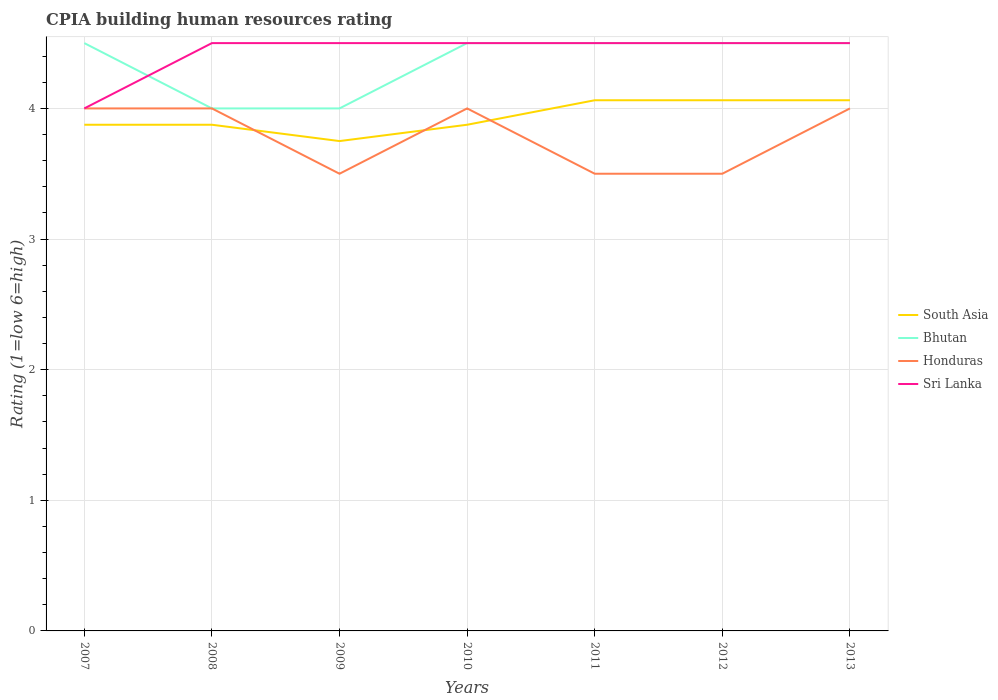Does the line corresponding to Sri Lanka intersect with the line corresponding to Bhutan?
Ensure brevity in your answer.  Yes. Across all years, what is the maximum CPIA rating in Honduras?
Offer a terse response. 3.5. What is the difference between the highest and the lowest CPIA rating in Honduras?
Keep it short and to the point. 4. How many years are there in the graph?
Provide a succinct answer. 7. Are the values on the major ticks of Y-axis written in scientific E-notation?
Offer a very short reply. No. Where does the legend appear in the graph?
Your answer should be very brief. Center right. What is the title of the graph?
Your answer should be very brief. CPIA building human resources rating. Does "Pacific island small states" appear as one of the legend labels in the graph?
Your response must be concise. No. What is the label or title of the Y-axis?
Provide a short and direct response. Rating (1=low 6=high). What is the Rating (1=low 6=high) in South Asia in 2007?
Provide a short and direct response. 3.88. What is the Rating (1=low 6=high) in Bhutan in 2007?
Your response must be concise. 4.5. What is the Rating (1=low 6=high) in Honduras in 2007?
Provide a succinct answer. 4. What is the Rating (1=low 6=high) in Sri Lanka in 2007?
Offer a very short reply. 4. What is the Rating (1=low 6=high) in South Asia in 2008?
Provide a succinct answer. 3.88. What is the Rating (1=low 6=high) of Sri Lanka in 2008?
Give a very brief answer. 4.5. What is the Rating (1=low 6=high) of South Asia in 2009?
Make the answer very short. 3.75. What is the Rating (1=low 6=high) in Honduras in 2009?
Offer a terse response. 3.5. What is the Rating (1=low 6=high) in Sri Lanka in 2009?
Offer a terse response. 4.5. What is the Rating (1=low 6=high) in South Asia in 2010?
Your response must be concise. 3.88. What is the Rating (1=low 6=high) of Bhutan in 2010?
Offer a very short reply. 4.5. What is the Rating (1=low 6=high) of Honduras in 2010?
Offer a terse response. 4. What is the Rating (1=low 6=high) of Sri Lanka in 2010?
Your answer should be compact. 4.5. What is the Rating (1=low 6=high) of South Asia in 2011?
Your response must be concise. 4.06. What is the Rating (1=low 6=high) in South Asia in 2012?
Your answer should be compact. 4.06. What is the Rating (1=low 6=high) of Bhutan in 2012?
Provide a short and direct response. 4.5. What is the Rating (1=low 6=high) in Honduras in 2012?
Make the answer very short. 3.5. What is the Rating (1=low 6=high) in Sri Lanka in 2012?
Your answer should be very brief. 4.5. What is the Rating (1=low 6=high) in South Asia in 2013?
Provide a short and direct response. 4.06. What is the Rating (1=low 6=high) of Bhutan in 2013?
Ensure brevity in your answer.  4.5. What is the Rating (1=low 6=high) in Honduras in 2013?
Your response must be concise. 4. What is the Rating (1=low 6=high) in Sri Lanka in 2013?
Your response must be concise. 4.5. Across all years, what is the maximum Rating (1=low 6=high) of South Asia?
Offer a very short reply. 4.06. Across all years, what is the maximum Rating (1=low 6=high) of Bhutan?
Your answer should be very brief. 4.5. Across all years, what is the maximum Rating (1=low 6=high) in Honduras?
Your response must be concise. 4. Across all years, what is the minimum Rating (1=low 6=high) in South Asia?
Provide a succinct answer. 3.75. Across all years, what is the minimum Rating (1=low 6=high) of Honduras?
Your answer should be compact. 3.5. What is the total Rating (1=low 6=high) in South Asia in the graph?
Provide a short and direct response. 27.56. What is the total Rating (1=low 6=high) of Bhutan in the graph?
Ensure brevity in your answer.  30.5. What is the total Rating (1=low 6=high) of Honduras in the graph?
Make the answer very short. 26.5. What is the total Rating (1=low 6=high) of Sri Lanka in the graph?
Your response must be concise. 31. What is the difference between the Rating (1=low 6=high) of South Asia in 2007 and that in 2008?
Ensure brevity in your answer.  0. What is the difference between the Rating (1=low 6=high) in Honduras in 2007 and that in 2008?
Your answer should be compact. 0. What is the difference between the Rating (1=low 6=high) in Sri Lanka in 2007 and that in 2008?
Make the answer very short. -0.5. What is the difference between the Rating (1=low 6=high) in South Asia in 2007 and that in 2009?
Ensure brevity in your answer.  0.12. What is the difference between the Rating (1=low 6=high) in Bhutan in 2007 and that in 2009?
Make the answer very short. 0.5. What is the difference between the Rating (1=low 6=high) of Honduras in 2007 and that in 2009?
Ensure brevity in your answer.  0.5. What is the difference between the Rating (1=low 6=high) of Sri Lanka in 2007 and that in 2009?
Your answer should be compact. -0.5. What is the difference between the Rating (1=low 6=high) in Bhutan in 2007 and that in 2010?
Give a very brief answer. 0. What is the difference between the Rating (1=low 6=high) in Sri Lanka in 2007 and that in 2010?
Offer a terse response. -0.5. What is the difference between the Rating (1=low 6=high) in South Asia in 2007 and that in 2011?
Offer a terse response. -0.19. What is the difference between the Rating (1=low 6=high) in Honduras in 2007 and that in 2011?
Your answer should be very brief. 0.5. What is the difference between the Rating (1=low 6=high) in South Asia in 2007 and that in 2012?
Provide a short and direct response. -0.19. What is the difference between the Rating (1=low 6=high) of South Asia in 2007 and that in 2013?
Provide a succinct answer. -0.19. What is the difference between the Rating (1=low 6=high) of Bhutan in 2008 and that in 2009?
Your answer should be very brief. 0. What is the difference between the Rating (1=low 6=high) of Sri Lanka in 2008 and that in 2009?
Offer a very short reply. 0. What is the difference between the Rating (1=low 6=high) of Honduras in 2008 and that in 2010?
Your response must be concise. 0. What is the difference between the Rating (1=low 6=high) of South Asia in 2008 and that in 2011?
Your answer should be very brief. -0.19. What is the difference between the Rating (1=low 6=high) in Sri Lanka in 2008 and that in 2011?
Offer a very short reply. 0. What is the difference between the Rating (1=low 6=high) in South Asia in 2008 and that in 2012?
Offer a very short reply. -0.19. What is the difference between the Rating (1=low 6=high) of Bhutan in 2008 and that in 2012?
Provide a short and direct response. -0.5. What is the difference between the Rating (1=low 6=high) in Honduras in 2008 and that in 2012?
Your answer should be very brief. 0.5. What is the difference between the Rating (1=low 6=high) in South Asia in 2008 and that in 2013?
Your answer should be very brief. -0.19. What is the difference between the Rating (1=low 6=high) of Bhutan in 2008 and that in 2013?
Offer a terse response. -0.5. What is the difference between the Rating (1=low 6=high) in Honduras in 2008 and that in 2013?
Your response must be concise. 0. What is the difference between the Rating (1=low 6=high) in South Asia in 2009 and that in 2010?
Your answer should be very brief. -0.12. What is the difference between the Rating (1=low 6=high) of Sri Lanka in 2009 and that in 2010?
Provide a short and direct response. 0. What is the difference between the Rating (1=low 6=high) of South Asia in 2009 and that in 2011?
Your answer should be compact. -0.31. What is the difference between the Rating (1=low 6=high) of South Asia in 2009 and that in 2012?
Your response must be concise. -0.31. What is the difference between the Rating (1=low 6=high) in Honduras in 2009 and that in 2012?
Keep it short and to the point. 0. What is the difference between the Rating (1=low 6=high) in South Asia in 2009 and that in 2013?
Your response must be concise. -0.31. What is the difference between the Rating (1=low 6=high) in South Asia in 2010 and that in 2011?
Provide a short and direct response. -0.19. What is the difference between the Rating (1=low 6=high) in Bhutan in 2010 and that in 2011?
Give a very brief answer. 0. What is the difference between the Rating (1=low 6=high) of Honduras in 2010 and that in 2011?
Provide a succinct answer. 0.5. What is the difference between the Rating (1=low 6=high) of Sri Lanka in 2010 and that in 2011?
Your answer should be compact. 0. What is the difference between the Rating (1=low 6=high) in South Asia in 2010 and that in 2012?
Your answer should be compact. -0.19. What is the difference between the Rating (1=low 6=high) in Bhutan in 2010 and that in 2012?
Your answer should be very brief. 0. What is the difference between the Rating (1=low 6=high) in Honduras in 2010 and that in 2012?
Provide a succinct answer. 0.5. What is the difference between the Rating (1=low 6=high) in Sri Lanka in 2010 and that in 2012?
Provide a succinct answer. 0. What is the difference between the Rating (1=low 6=high) of South Asia in 2010 and that in 2013?
Your response must be concise. -0.19. What is the difference between the Rating (1=low 6=high) in Bhutan in 2010 and that in 2013?
Keep it short and to the point. 0. What is the difference between the Rating (1=low 6=high) of Bhutan in 2011 and that in 2012?
Provide a succinct answer. 0. What is the difference between the Rating (1=low 6=high) of South Asia in 2011 and that in 2013?
Your answer should be very brief. 0. What is the difference between the Rating (1=low 6=high) of Bhutan in 2011 and that in 2013?
Give a very brief answer. 0. What is the difference between the Rating (1=low 6=high) of Sri Lanka in 2011 and that in 2013?
Ensure brevity in your answer.  0. What is the difference between the Rating (1=low 6=high) of Bhutan in 2012 and that in 2013?
Keep it short and to the point. 0. What is the difference between the Rating (1=low 6=high) of South Asia in 2007 and the Rating (1=low 6=high) of Bhutan in 2008?
Your response must be concise. -0.12. What is the difference between the Rating (1=low 6=high) of South Asia in 2007 and the Rating (1=low 6=high) of Honduras in 2008?
Your response must be concise. -0.12. What is the difference between the Rating (1=low 6=high) of South Asia in 2007 and the Rating (1=low 6=high) of Sri Lanka in 2008?
Keep it short and to the point. -0.62. What is the difference between the Rating (1=low 6=high) of Bhutan in 2007 and the Rating (1=low 6=high) of Honduras in 2008?
Keep it short and to the point. 0.5. What is the difference between the Rating (1=low 6=high) of Honduras in 2007 and the Rating (1=low 6=high) of Sri Lanka in 2008?
Make the answer very short. -0.5. What is the difference between the Rating (1=low 6=high) in South Asia in 2007 and the Rating (1=low 6=high) in Bhutan in 2009?
Provide a short and direct response. -0.12. What is the difference between the Rating (1=low 6=high) of South Asia in 2007 and the Rating (1=low 6=high) of Sri Lanka in 2009?
Your answer should be compact. -0.62. What is the difference between the Rating (1=low 6=high) of Bhutan in 2007 and the Rating (1=low 6=high) of Honduras in 2009?
Offer a very short reply. 1. What is the difference between the Rating (1=low 6=high) in Bhutan in 2007 and the Rating (1=low 6=high) in Sri Lanka in 2009?
Give a very brief answer. 0. What is the difference between the Rating (1=low 6=high) of Honduras in 2007 and the Rating (1=low 6=high) of Sri Lanka in 2009?
Your response must be concise. -0.5. What is the difference between the Rating (1=low 6=high) of South Asia in 2007 and the Rating (1=low 6=high) of Bhutan in 2010?
Ensure brevity in your answer.  -0.62. What is the difference between the Rating (1=low 6=high) in South Asia in 2007 and the Rating (1=low 6=high) in Honduras in 2010?
Give a very brief answer. -0.12. What is the difference between the Rating (1=low 6=high) in South Asia in 2007 and the Rating (1=low 6=high) in Sri Lanka in 2010?
Provide a short and direct response. -0.62. What is the difference between the Rating (1=low 6=high) of Bhutan in 2007 and the Rating (1=low 6=high) of Honduras in 2010?
Offer a very short reply. 0.5. What is the difference between the Rating (1=low 6=high) of South Asia in 2007 and the Rating (1=low 6=high) of Bhutan in 2011?
Make the answer very short. -0.62. What is the difference between the Rating (1=low 6=high) of South Asia in 2007 and the Rating (1=low 6=high) of Honduras in 2011?
Keep it short and to the point. 0.38. What is the difference between the Rating (1=low 6=high) of South Asia in 2007 and the Rating (1=low 6=high) of Sri Lanka in 2011?
Your response must be concise. -0.62. What is the difference between the Rating (1=low 6=high) in Bhutan in 2007 and the Rating (1=low 6=high) in Sri Lanka in 2011?
Your answer should be compact. 0. What is the difference between the Rating (1=low 6=high) of South Asia in 2007 and the Rating (1=low 6=high) of Bhutan in 2012?
Offer a very short reply. -0.62. What is the difference between the Rating (1=low 6=high) of South Asia in 2007 and the Rating (1=low 6=high) of Honduras in 2012?
Your answer should be compact. 0.38. What is the difference between the Rating (1=low 6=high) in South Asia in 2007 and the Rating (1=low 6=high) in Sri Lanka in 2012?
Provide a succinct answer. -0.62. What is the difference between the Rating (1=low 6=high) in Bhutan in 2007 and the Rating (1=low 6=high) in Honduras in 2012?
Your response must be concise. 1. What is the difference between the Rating (1=low 6=high) in Bhutan in 2007 and the Rating (1=low 6=high) in Sri Lanka in 2012?
Offer a very short reply. 0. What is the difference between the Rating (1=low 6=high) of Honduras in 2007 and the Rating (1=low 6=high) of Sri Lanka in 2012?
Provide a succinct answer. -0.5. What is the difference between the Rating (1=low 6=high) of South Asia in 2007 and the Rating (1=low 6=high) of Bhutan in 2013?
Keep it short and to the point. -0.62. What is the difference between the Rating (1=low 6=high) of South Asia in 2007 and the Rating (1=low 6=high) of Honduras in 2013?
Your response must be concise. -0.12. What is the difference between the Rating (1=low 6=high) of South Asia in 2007 and the Rating (1=low 6=high) of Sri Lanka in 2013?
Ensure brevity in your answer.  -0.62. What is the difference between the Rating (1=low 6=high) in Bhutan in 2007 and the Rating (1=low 6=high) in Honduras in 2013?
Provide a short and direct response. 0.5. What is the difference between the Rating (1=low 6=high) of Honduras in 2007 and the Rating (1=low 6=high) of Sri Lanka in 2013?
Provide a succinct answer. -0.5. What is the difference between the Rating (1=low 6=high) of South Asia in 2008 and the Rating (1=low 6=high) of Bhutan in 2009?
Keep it short and to the point. -0.12. What is the difference between the Rating (1=low 6=high) in South Asia in 2008 and the Rating (1=low 6=high) in Sri Lanka in 2009?
Your answer should be very brief. -0.62. What is the difference between the Rating (1=low 6=high) in Bhutan in 2008 and the Rating (1=low 6=high) in Honduras in 2009?
Give a very brief answer. 0.5. What is the difference between the Rating (1=low 6=high) in South Asia in 2008 and the Rating (1=low 6=high) in Bhutan in 2010?
Ensure brevity in your answer.  -0.62. What is the difference between the Rating (1=low 6=high) in South Asia in 2008 and the Rating (1=low 6=high) in Honduras in 2010?
Keep it short and to the point. -0.12. What is the difference between the Rating (1=low 6=high) in South Asia in 2008 and the Rating (1=low 6=high) in Sri Lanka in 2010?
Your answer should be compact. -0.62. What is the difference between the Rating (1=low 6=high) of Bhutan in 2008 and the Rating (1=low 6=high) of Honduras in 2010?
Your response must be concise. 0. What is the difference between the Rating (1=low 6=high) of South Asia in 2008 and the Rating (1=low 6=high) of Bhutan in 2011?
Your response must be concise. -0.62. What is the difference between the Rating (1=low 6=high) in South Asia in 2008 and the Rating (1=low 6=high) in Sri Lanka in 2011?
Provide a succinct answer. -0.62. What is the difference between the Rating (1=low 6=high) in Bhutan in 2008 and the Rating (1=low 6=high) in Honduras in 2011?
Keep it short and to the point. 0.5. What is the difference between the Rating (1=low 6=high) of Bhutan in 2008 and the Rating (1=low 6=high) of Sri Lanka in 2011?
Your response must be concise. -0.5. What is the difference between the Rating (1=low 6=high) of South Asia in 2008 and the Rating (1=low 6=high) of Bhutan in 2012?
Your response must be concise. -0.62. What is the difference between the Rating (1=low 6=high) in South Asia in 2008 and the Rating (1=low 6=high) in Sri Lanka in 2012?
Keep it short and to the point. -0.62. What is the difference between the Rating (1=low 6=high) in Honduras in 2008 and the Rating (1=low 6=high) in Sri Lanka in 2012?
Offer a terse response. -0.5. What is the difference between the Rating (1=low 6=high) of South Asia in 2008 and the Rating (1=low 6=high) of Bhutan in 2013?
Your response must be concise. -0.62. What is the difference between the Rating (1=low 6=high) in South Asia in 2008 and the Rating (1=low 6=high) in Honduras in 2013?
Make the answer very short. -0.12. What is the difference between the Rating (1=low 6=high) in South Asia in 2008 and the Rating (1=low 6=high) in Sri Lanka in 2013?
Ensure brevity in your answer.  -0.62. What is the difference between the Rating (1=low 6=high) of Bhutan in 2008 and the Rating (1=low 6=high) of Sri Lanka in 2013?
Make the answer very short. -0.5. What is the difference between the Rating (1=low 6=high) of South Asia in 2009 and the Rating (1=low 6=high) of Bhutan in 2010?
Provide a succinct answer. -0.75. What is the difference between the Rating (1=low 6=high) of South Asia in 2009 and the Rating (1=low 6=high) of Sri Lanka in 2010?
Your response must be concise. -0.75. What is the difference between the Rating (1=low 6=high) in South Asia in 2009 and the Rating (1=low 6=high) in Bhutan in 2011?
Your answer should be compact. -0.75. What is the difference between the Rating (1=low 6=high) in South Asia in 2009 and the Rating (1=low 6=high) in Sri Lanka in 2011?
Your response must be concise. -0.75. What is the difference between the Rating (1=low 6=high) of Bhutan in 2009 and the Rating (1=low 6=high) of Sri Lanka in 2011?
Give a very brief answer. -0.5. What is the difference between the Rating (1=low 6=high) of Honduras in 2009 and the Rating (1=low 6=high) of Sri Lanka in 2011?
Ensure brevity in your answer.  -1. What is the difference between the Rating (1=low 6=high) of South Asia in 2009 and the Rating (1=low 6=high) of Bhutan in 2012?
Your answer should be very brief. -0.75. What is the difference between the Rating (1=low 6=high) in South Asia in 2009 and the Rating (1=low 6=high) in Honduras in 2012?
Keep it short and to the point. 0.25. What is the difference between the Rating (1=low 6=high) of South Asia in 2009 and the Rating (1=low 6=high) of Sri Lanka in 2012?
Your answer should be compact. -0.75. What is the difference between the Rating (1=low 6=high) of Bhutan in 2009 and the Rating (1=low 6=high) of Honduras in 2012?
Make the answer very short. 0.5. What is the difference between the Rating (1=low 6=high) in Bhutan in 2009 and the Rating (1=low 6=high) in Sri Lanka in 2012?
Your answer should be very brief. -0.5. What is the difference between the Rating (1=low 6=high) in South Asia in 2009 and the Rating (1=low 6=high) in Bhutan in 2013?
Keep it short and to the point. -0.75. What is the difference between the Rating (1=low 6=high) of South Asia in 2009 and the Rating (1=low 6=high) of Sri Lanka in 2013?
Your response must be concise. -0.75. What is the difference between the Rating (1=low 6=high) in Bhutan in 2009 and the Rating (1=low 6=high) in Honduras in 2013?
Give a very brief answer. 0. What is the difference between the Rating (1=low 6=high) in South Asia in 2010 and the Rating (1=low 6=high) in Bhutan in 2011?
Your answer should be compact. -0.62. What is the difference between the Rating (1=low 6=high) in South Asia in 2010 and the Rating (1=low 6=high) in Sri Lanka in 2011?
Keep it short and to the point. -0.62. What is the difference between the Rating (1=low 6=high) in Bhutan in 2010 and the Rating (1=low 6=high) in Sri Lanka in 2011?
Your response must be concise. 0. What is the difference between the Rating (1=low 6=high) of Honduras in 2010 and the Rating (1=low 6=high) of Sri Lanka in 2011?
Keep it short and to the point. -0.5. What is the difference between the Rating (1=low 6=high) in South Asia in 2010 and the Rating (1=low 6=high) in Bhutan in 2012?
Give a very brief answer. -0.62. What is the difference between the Rating (1=low 6=high) of South Asia in 2010 and the Rating (1=low 6=high) of Honduras in 2012?
Offer a terse response. 0.38. What is the difference between the Rating (1=low 6=high) in South Asia in 2010 and the Rating (1=low 6=high) in Sri Lanka in 2012?
Keep it short and to the point. -0.62. What is the difference between the Rating (1=low 6=high) of Bhutan in 2010 and the Rating (1=low 6=high) of Sri Lanka in 2012?
Your answer should be very brief. 0. What is the difference between the Rating (1=low 6=high) of South Asia in 2010 and the Rating (1=low 6=high) of Bhutan in 2013?
Ensure brevity in your answer.  -0.62. What is the difference between the Rating (1=low 6=high) of South Asia in 2010 and the Rating (1=low 6=high) of Honduras in 2013?
Provide a short and direct response. -0.12. What is the difference between the Rating (1=low 6=high) in South Asia in 2010 and the Rating (1=low 6=high) in Sri Lanka in 2013?
Your answer should be compact. -0.62. What is the difference between the Rating (1=low 6=high) of South Asia in 2011 and the Rating (1=low 6=high) of Bhutan in 2012?
Your answer should be compact. -0.44. What is the difference between the Rating (1=low 6=high) in South Asia in 2011 and the Rating (1=low 6=high) in Honduras in 2012?
Give a very brief answer. 0.56. What is the difference between the Rating (1=low 6=high) of South Asia in 2011 and the Rating (1=low 6=high) of Sri Lanka in 2012?
Make the answer very short. -0.44. What is the difference between the Rating (1=low 6=high) in Bhutan in 2011 and the Rating (1=low 6=high) in Honduras in 2012?
Make the answer very short. 1. What is the difference between the Rating (1=low 6=high) in Honduras in 2011 and the Rating (1=low 6=high) in Sri Lanka in 2012?
Ensure brevity in your answer.  -1. What is the difference between the Rating (1=low 6=high) in South Asia in 2011 and the Rating (1=low 6=high) in Bhutan in 2013?
Your answer should be very brief. -0.44. What is the difference between the Rating (1=low 6=high) of South Asia in 2011 and the Rating (1=low 6=high) of Honduras in 2013?
Make the answer very short. 0.06. What is the difference between the Rating (1=low 6=high) in South Asia in 2011 and the Rating (1=low 6=high) in Sri Lanka in 2013?
Your answer should be very brief. -0.44. What is the difference between the Rating (1=low 6=high) of South Asia in 2012 and the Rating (1=low 6=high) of Bhutan in 2013?
Your answer should be very brief. -0.44. What is the difference between the Rating (1=low 6=high) of South Asia in 2012 and the Rating (1=low 6=high) of Honduras in 2013?
Your answer should be compact. 0.06. What is the difference between the Rating (1=low 6=high) of South Asia in 2012 and the Rating (1=low 6=high) of Sri Lanka in 2013?
Provide a succinct answer. -0.44. What is the difference between the Rating (1=low 6=high) in Honduras in 2012 and the Rating (1=low 6=high) in Sri Lanka in 2013?
Your answer should be very brief. -1. What is the average Rating (1=low 6=high) of South Asia per year?
Give a very brief answer. 3.94. What is the average Rating (1=low 6=high) in Bhutan per year?
Ensure brevity in your answer.  4.36. What is the average Rating (1=low 6=high) in Honduras per year?
Your response must be concise. 3.79. What is the average Rating (1=low 6=high) of Sri Lanka per year?
Your response must be concise. 4.43. In the year 2007, what is the difference between the Rating (1=low 6=high) in South Asia and Rating (1=low 6=high) in Bhutan?
Provide a short and direct response. -0.62. In the year 2007, what is the difference between the Rating (1=low 6=high) in South Asia and Rating (1=low 6=high) in Honduras?
Your answer should be very brief. -0.12. In the year 2007, what is the difference between the Rating (1=low 6=high) of South Asia and Rating (1=low 6=high) of Sri Lanka?
Make the answer very short. -0.12. In the year 2007, what is the difference between the Rating (1=low 6=high) of Bhutan and Rating (1=low 6=high) of Honduras?
Offer a very short reply. 0.5. In the year 2008, what is the difference between the Rating (1=low 6=high) of South Asia and Rating (1=low 6=high) of Bhutan?
Make the answer very short. -0.12. In the year 2008, what is the difference between the Rating (1=low 6=high) in South Asia and Rating (1=low 6=high) in Honduras?
Keep it short and to the point. -0.12. In the year 2008, what is the difference between the Rating (1=low 6=high) of South Asia and Rating (1=low 6=high) of Sri Lanka?
Your answer should be very brief. -0.62. In the year 2008, what is the difference between the Rating (1=low 6=high) in Bhutan and Rating (1=low 6=high) in Honduras?
Make the answer very short. 0. In the year 2009, what is the difference between the Rating (1=low 6=high) of South Asia and Rating (1=low 6=high) of Honduras?
Your response must be concise. 0.25. In the year 2009, what is the difference between the Rating (1=low 6=high) of South Asia and Rating (1=low 6=high) of Sri Lanka?
Ensure brevity in your answer.  -0.75. In the year 2009, what is the difference between the Rating (1=low 6=high) in Bhutan and Rating (1=low 6=high) in Honduras?
Provide a short and direct response. 0.5. In the year 2009, what is the difference between the Rating (1=low 6=high) of Bhutan and Rating (1=low 6=high) of Sri Lanka?
Offer a terse response. -0.5. In the year 2010, what is the difference between the Rating (1=low 6=high) in South Asia and Rating (1=low 6=high) in Bhutan?
Your response must be concise. -0.62. In the year 2010, what is the difference between the Rating (1=low 6=high) in South Asia and Rating (1=low 6=high) in Honduras?
Make the answer very short. -0.12. In the year 2010, what is the difference between the Rating (1=low 6=high) of South Asia and Rating (1=low 6=high) of Sri Lanka?
Your response must be concise. -0.62. In the year 2010, what is the difference between the Rating (1=low 6=high) in Bhutan and Rating (1=low 6=high) in Honduras?
Offer a very short reply. 0.5. In the year 2010, what is the difference between the Rating (1=low 6=high) of Bhutan and Rating (1=low 6=high) of Sri Lanka?
Your answer should be very brief. 0. In the year 2010, what is the difference between the Rating (1=low 6=high) of Honduras and Rating (1=low 6=high) of Sri Lanka?
Offer a very short reply. -0.5. In the year 2011, what is the difference between the Rating (1=low 6=high) in South Asia and Rating (1=low 6=high) in Bhutan?
Your response must be concise. -0.44. In the year 2011, what is the difference between the Rating (1=low 6=high) of South Asia and Rating (1=low 6=high) of Honduras?
Ensure brevity in your answer.  0.56. In the year 2011, what is the difference between the Rating (1=low 6=high) of South Asia and Rating (1=low 6=high) of Sri Lanka?
Give a very brief answer. -0.44. In the year 2011, what is the difference between the Rating (1=low 6=high) of Bhutan and Rating (1=low 6=high) of Honduras?
Give a very brief answer. 1. In the year 2011, what is the difference between the Rating (1=low 6=high) in Honduras and Rating (1=low 6=high) in Sri Lanka?
Provide a succinct answer. -1. In the year 2012, what is the difference between the Rating (1=low 6=high) of South Asia and Rating (1=low 6=high) of Bhutan?
Your response must be concise. -0.44. In the year 2012, what is the difference between the Rating (1=low 6=high) in South Asia and Rating (1=low 6=high) in Honduras?
Offer a terse response. 0.56. In the year 2012, what is the difference between the Rating (1=low 6=high) of South Asia and Rating (1=low 6=high) of Sri Lanka?
Make the answer very short. -0.44. In the year 2012, what is the difference between the Rating (1=low 6=high) of Bhutan and Rating (1=low 6=high) of Honduras?
Keep it short and to the point. 1. In the year 2012, what is the difference between the Rating (1=low 6=high) of Honduras and Rating (1=low 6=high) of Sri Lanka?
Your answer should be compact. -1. In the year 2013, what is the difference between the Rating (1=low 6=high) in South Asia and Rating (1=low 6=high) in Bhutan?
Your answer should be compact. -0.44. In the year 2013, what is the difference between the Rating (1=low 6=high) in South Asia and Rating (1=low 6=high) in Honduras?
Keep it short and to the point. 0.06. In the year 2013, what is the difference between the Rating (1=low 6=high) in South Asia and Rating (1=low 6=high) in Sri Lanka?
Give a very brief answer. -0.44. What is the ratio of the Rating (1=low 6=high) of South Asia in 2007 to that in 2008?
Offer a terse response. 1. What is the ratio of the Rating (1=low 6=high) in Bhutan in 2007 to that in 2008?
Provide a short and direct response. 1.12. What is the ratio of the Rating (1=low 6=high) of Sri Lanka in 2007 to that in 2008?
Ensure brevity in your answer.  0.89. What is the ratio of the Rating (1=low 6=high) of South Asia in 2007 to that in 2009?
Make the answer very short. 1.03. What is the ratio of the Rating (1=low 6=high) of South Asia in 2007 to that in 2010?
Your answer should be very brief. 1. What is the ratio of the Rating (1=low 6=high) in South Asia in 2007 to that in 2011?
Provide a succinct answer. 0.95. What is the ratio of the Rating (1=low 6=high) of Honduras in 2007 to that in 2011?
Your answer should be very brief. 1.14. What is the ratio of the Rating (1=low 6=high) in South Asia in 2007 to that in 2012?
Make the answer very short. 0.95. What is the ratio of the Rating (1=low 6=high) of Bhutan in 2007 to that in 2012?
Your answer should be very brief. 1. What is the ratio of the Rating (1=low 6=high) in Honduras in 2007 to that in 2012?
Keep it short and to the point. 1.14. What is the ratio of the Rating (1=low 6=high) of South Asia in 2007 to that in 2013?
Give a very brief answer. 0.95. What is the ratio of the Rating (1=low 6=high) of Honduras in 2007 to that in 2013?
Offer a terse response. 1. What is the ratio of the Rating (1=low 6=high) in South Asia in 2008 to that in 2010?
Ensure brevity in your answer.  1. What is the ratio of the Rating (1=low 6=high) of Bhutan in 2008 to that in 2010?
Make the answer very short. 0.89. What is the ratio of the Rating (1=low 6=high) in Honduras in 2008 to that in 2010?
Provide a short and direct response. 1. What is the ratio of the Rating (1=low 6=high) of South Asia in 2008 to that in 2011?
Keep it short and to the point. 0.95. What is the ratio of the Rating (1=low 6=high) of Bhutan in 2008 to that in 2011?
Your response must be concise. 0.89. What is the ratio of the Rating (1=low 6=high) of Sri Lanka in 2008 to that in 2011?
Your answer should be very brief. 1. What is the ratio of the Rating (1=low 6=high) in South Asia in 2008 to that in 2012?
Make the answer very short. 0.95. What is the ratio of the Rating (1=low 6=high) in Bhutan in 2008 to that in 2012?
Give a very brief answer. 0.89. What is the ratio of the Rating (1=low 6=high) of South Asia in 2008 to that in 2013?
Ensure brevity in your answer.  0.95. What is the ratio of the Rating (1=low 6=high) of Bhutan in 2008 to that in 2013?
Offer a very short reply. 0.89. What is the ratio of the Rating (1=low 6=high) in Sri Lanka in 2009 to that in 2011?
Ensure brevity in your answer.  1. What is the ratio of the Rating (1=low 6=high) of South Asia in 2009 to that in 2012?
Make the answer very short. 0.92. What is the ratio of the Rating (1=low 6=high) in Sri Lanka in 2009 to that in 2012?
Offer a very short reply. 1. What is the ratio of the Rating (1=low 6=high) in Bhutan in 2009 to that in 2013?
Your response must be concise. 0.89. What is the ratio of the Rating (1=low 6=high) of Honduras in 2009 to that in 2013?
Provide a succinct answer. 0.88. What is the ratio of the Rating (1=low 6=high) of Sri Lanka in 2009 to that in 2013?
Ensure brevity in your answer.  1. What is the ratio of the Rating (1=low 6=high) in South Asia in 2010 to that in 2011?
Provide a succinct answer. 0.95. What is the ratio of the Rating (1=low 6=high) in Honduras in 2010 to that in 2011?
Your answer should be compact. 1.14. What is the ratio of the Rating (1=low 6=high) of South Asia in 2010 to that in 2012?
Offer a terse response. 0.95. What is the ratio of the Rating (1=low 6=high) of Bhutan in 2010 to that in 2012?
Provide a short and direct response. 1. What is the ratio of the Rating (1=low 6=high) of South Asia in 2010 to that in 2013?
Your answer should be compact. 0.95. What is the ratio of the Rating (1=low 6=high) in Bhutan in 2010 to that in 2013?
Keep it short and to the point. 1. What is the ratio of the Rating (1=low 6=high) of South Asia in 2011 to that in 2012?
Offer a terse response. 1. What is the ratio of the Rating (1=low 6=high) in Honduras in 2011 to that in 2012?
Your answer should be very brief. 1. What is the ratio of the Rating (1=low 6=high) of Sri Lanka in 2011 to that in 2012?
Give a very brief answer. 1. What is the ratio of the Rating (1=low 6=high) in South Asia in 2011 to that in 2013?
Ensure brevity in your answer.  1. What is the ratio of the Rating (1=low 6=high) of Bhutan in 2011 to that in 2013?
Make the answer very short. 1. What is the ratio of the Rating (1=low 6=high) in Honduras in 2011 to that in 2013?
Ensure brevity in your answer.  0.88. What is the ratio of the Rating (1=low 6=high) of Sri Lanka in 2011 to that in 2013?
Provide a succinct answer. 1. What is the ratio of the Rating (1=low 6=high) of South Asia in 2012 to that in 2013?
Provide a succinct answer. 1. What is the ratio of the Rating (1=low 6=high) in Bhutan in 2012 to that in 2013?
Ensure brevity in your answer.  1. What is the ratio of the Rating (1=low 6=high) in Honduras in 2012 to that in 2013?
Your answer should be very brief. 0.88. What is the ratio of the Rating (1=low 6=high) of Sri Lanka in 2012 to that in 2013?
Provide a short and direct response. 1. What is the difference between the highest and the second highest Rating (1=low 6=high) of South Asia?
Your answer should be very brief. 0. What is the difference between the highest and the second highest Rating (1=low 6=high) in Bhutan?
Your response must be concise. 0. What is the difference between the highest and the second highest Rating (1=low 6=high) in Honduras?
Make the answer very short. 0. What is the difference between the highest and the second highest Rating (1=low 6=high) of Sri Lanka?
Keep it short and to the point. 0. What is the difference between the highest and the lowest Rating (1=low 6=high) in South Asia?
Keep it short and to the point. 0.31. What is the difference between the highest and the lowest Rating (1=low 6=high) of Sri Lanka?
Make the answer very short. 0.5. 